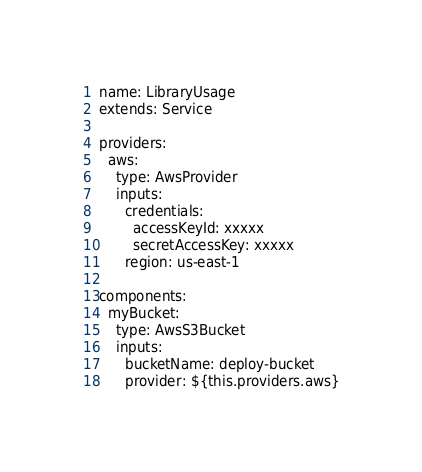<code> <loc_0><loc_0><loc_500><loc_500><_YAML_>name: LibraryUsage
extends: Service

providers:
  aws:
    type: AwsProvider
    inputs:
      credentials:
        accessKeyId: xxxxx
        secretAccessKey: xxxxx
      region: us-east-1

components:
  myBucket:
    type: AwsS3Bucket
    inputs:
      bucketName: deploy-bucket
      provider: ${this.providers.aws}
</code> 